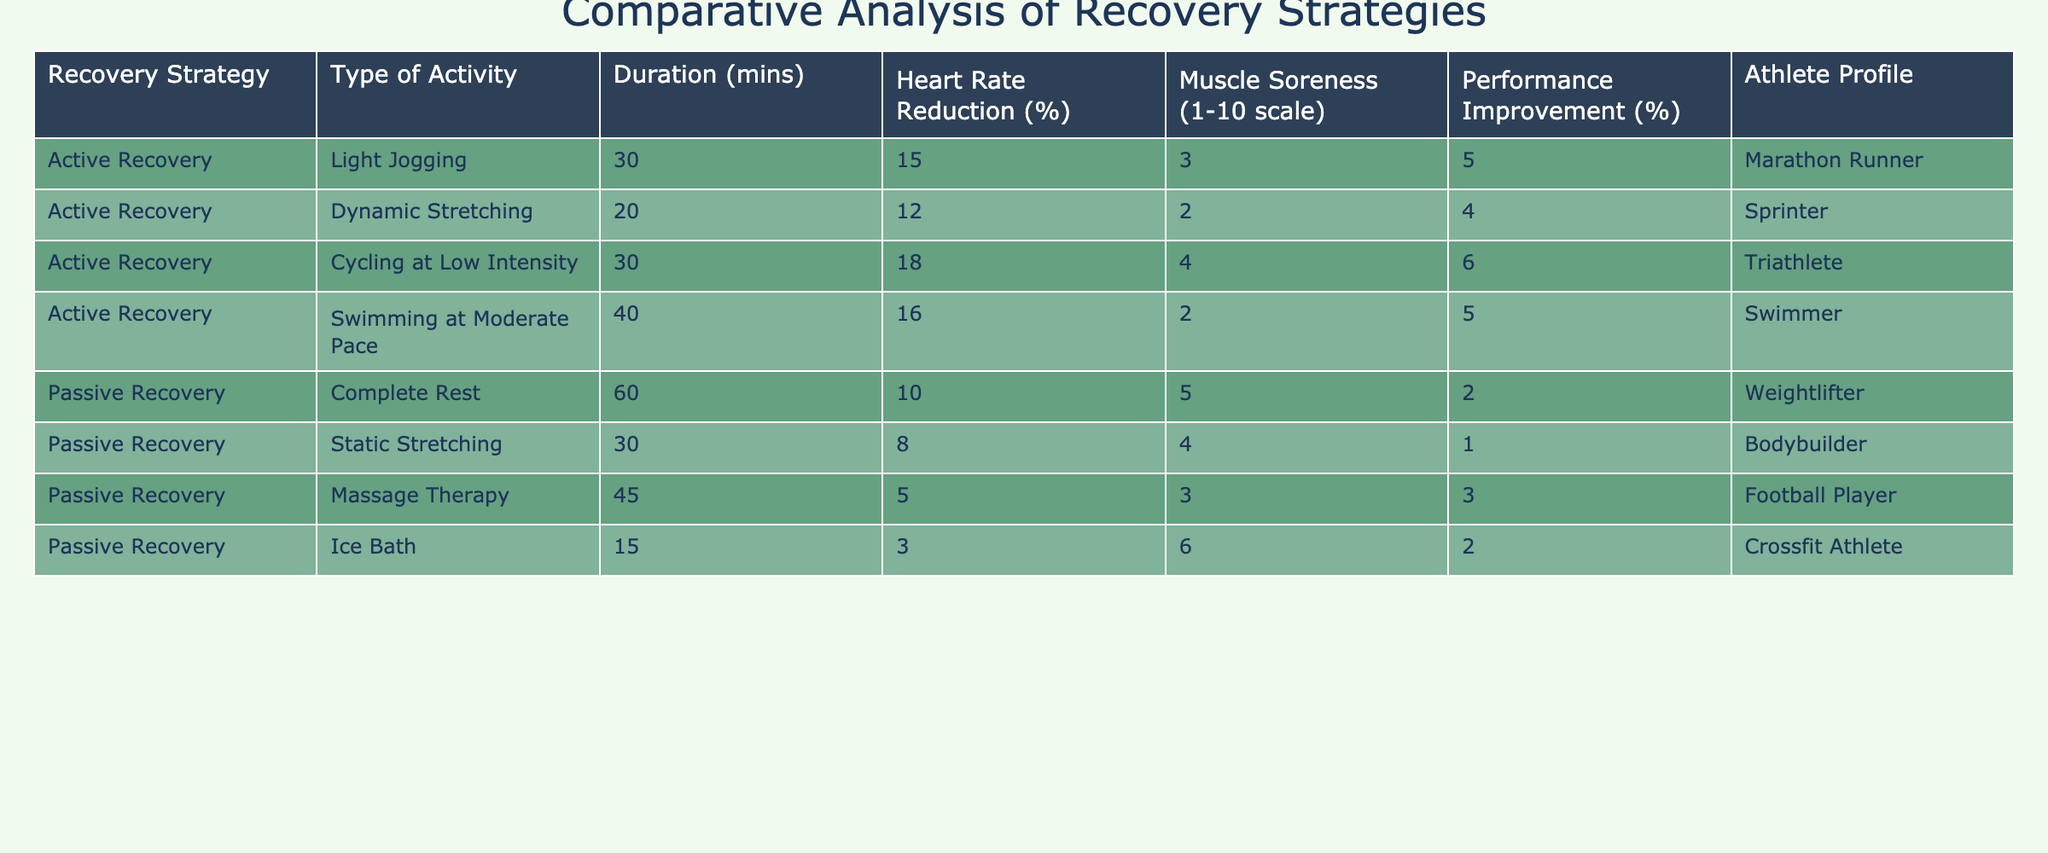What is the heart rate reduction for dynamic stretching? The table lists heart rate reduction percentages for various activities. For dynamic stretching, the heart rate reduction is noted as 12%.
Answer: 12% Which recovery strategy shows the highest performance improvement? By comparing the performance improvement percentages across all strategies, ice bath shows the highest improvement at 6%.
Answer: 6% What is the average muscle soreness rating across all active recovery strategies? The muscle soreness ratings for active recovery are 3, 2, 4, and 2. Summing these gives 11, and dividing by the number of activities (4) results in an average of 2.75.
Answer: 2.75 Does massage therapy provide a greater heart rate reduction than static stretching? Massage therapy has a heart rate reduction of 5%, while static stretching has a reduction of 8%. Since 5% is less than 8%, the answer is no.
Answer: No Which athlete profile experienced the least muscle soreness in active recovery? By checking the muscle soreness ratings for active recovery, dynamic stretching and swimming both have a soreness rating of 2, which is the lowest.
Answer: Dynamic Stretching and Swimming What is the difference in heart rate reduction between cycling at low intensity and complete rest? Cycling at low intensity has a heart rate reduction of 18%, while complete rest has a reduction of 10%. The difference is 18% - 10% = 8%.
Answer: 8% Which recovery strategy resulted in a muscle soreness rating of 5? The table shows that the muscle soreness rating of 5 corresponds to complete rest.
Answer: Complete Rest Is passive recovery more effective than active recovery in terms of performance improvement? The highest performance improvement for passive recovery is 2%, while active recovery has performance improvements of 4%, 5%, and 6%. Thus, active recovery is more effective.
Answer: No What is the total duration of active recovery strategies listed? The durations for active recovery strategies are 30, 20, 30, and 40 minutes, totaling 30 + 20 + 30 + 40 = 120 minutes.
Answer: 120 minutes Among the recovery strategies, which one had the lowest heart rate reduction and what was its value? By examining heart rate reductions, ice bath has the lowest at 3%.
Answer: 3% 